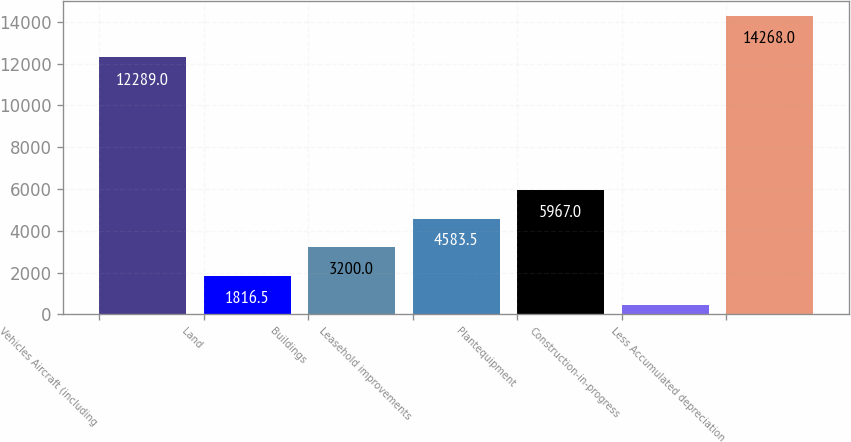<chart> <loc_0><loc_0><loc_500><loc_500><bar_chart><fcel>Vehicles Aircraft (including<fcel>Land<fcel>Buildings<fcel>Leasehold improvements<fcel>Plantequipment<fcel>Construction-in-progress<fcel>Less Accumulated depreciation<nl><fcel>12289<fcel>1816.5<fcel>3200<fcel>4583.5<fcel>5967<fcel>433<fcel>14268<nl></chart> 